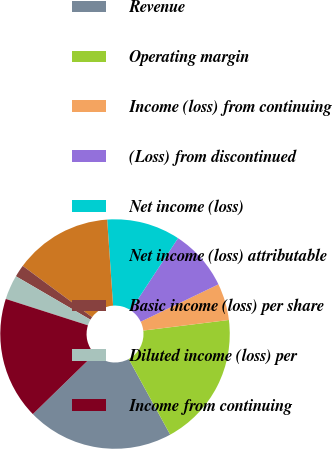<chart> <loc_0><loc_0><loc_500><loc_500><pie_chart><fcel>Revenue<fcel>Operating margin<fcel>Income (loss) from continuing<fcel>(Loss) from discontinued<fcel>Net income (loss)<fcel>Net income (loss) attributable<fcel>Basic income (loss) per share<fcel>Diluted income (loss) per<fcel>Income from continuing<nl><fcel>20.69%<fcel>18.97%<fcel>5.17%<fcel>8.62%<fcel>10.34%<fcel>13.79%<fcel>1.72%<fcel>3.45%<fcel>17.24%<nl></chart> 